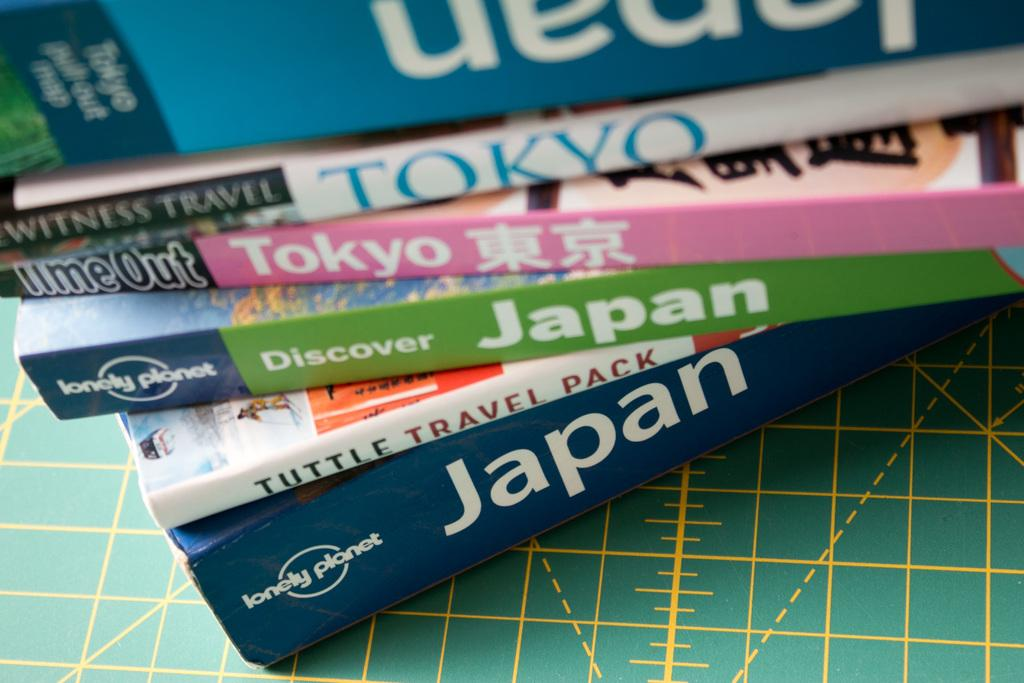<image>
Provide a brief description of the given image. a stack of books with the one on the bottom titled 'japan' 